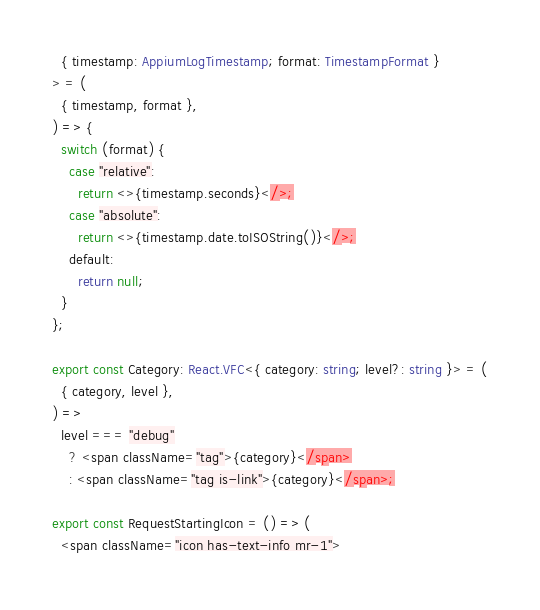Convert code to text. <code><loc_0><loc_0><loc_500><loc_500><_TypeScript_>  { timestamp: AppiumLogTimestamp; format: TimestampFormat }
> = (
  { timestamp, format },
) => {
  switch (format) {
    case "relative":
      return <>{timestamp.seconds}</>;
    case "absolute":
      return <>{timestamp.date.toISOString()}</>;
    default:
      return null;
  }
};

export const Category: React.VFC<{ category: string; level?: string }> = (
  { category, level },
) =>
  level === "debug"
    ? <span className="tag">{category}</span>
    : <span className="tag is-link">{category}</span>;

export const RequestStartingIcon = () => (
  <span className="icon has-text-info mr-1"></code> 